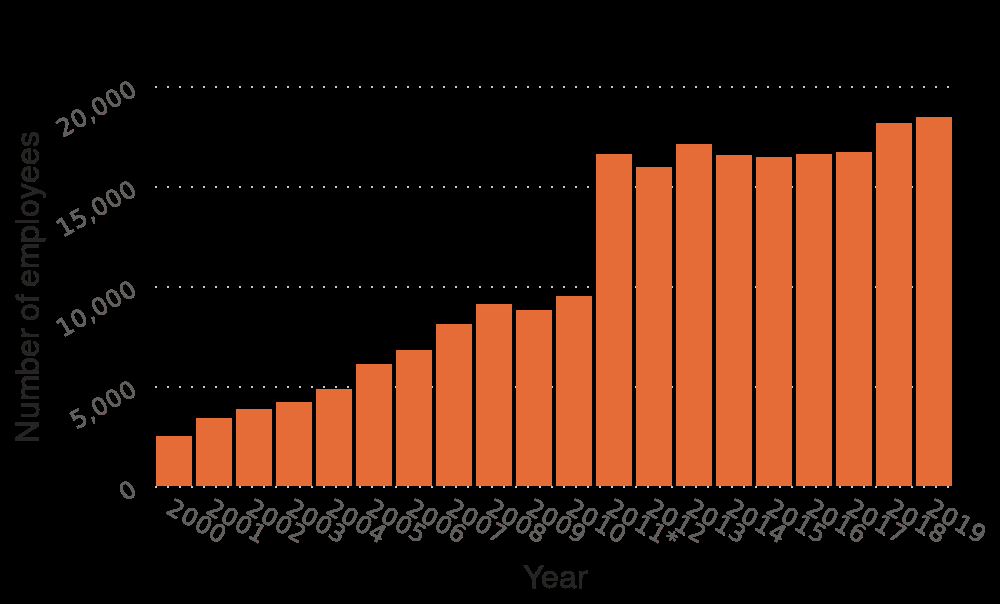<image>
please describe the details of the chart This is a bar chart titled Number of Ipsos employees worldwide from 2000 to 2019. The y-axis plots Number of employees while the x-axis shows Year. What significant change occurred in the number of Ipsos employees worldwide from 2010 to 2011?  There was a major spike in the number of Ipsos employees worldwide, rising from just below 10000 to just above 15000. 